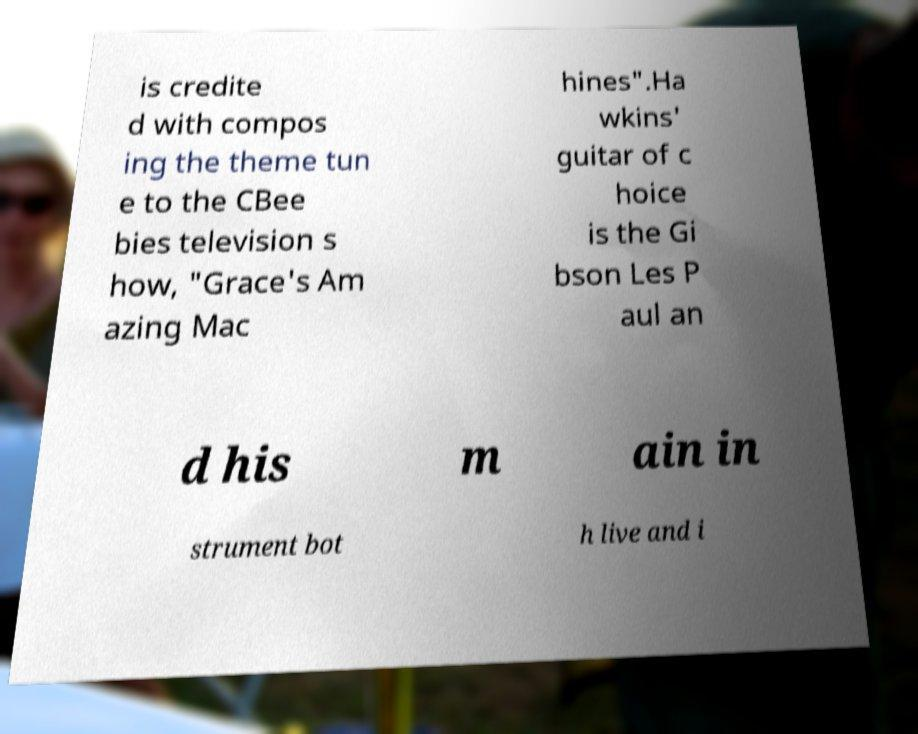Please read and relay the text visible in this image. What does it say? is credite d with compos ing the theme tun e to the CBee bies television s how, "Grace's Am azing Mac hines".Ha wkins' guitar of c hoice is the Gi bson Les P aul an d his m ain in strument bot h live and i 